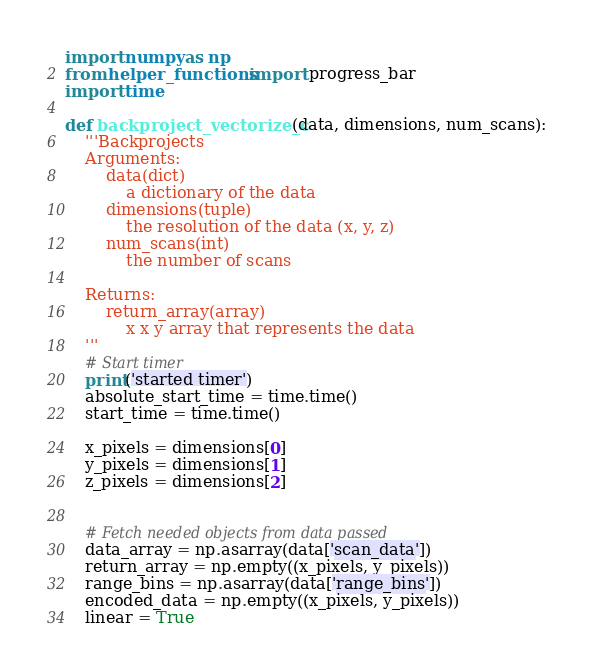<code> <loc_0><loc_0><loc_500><loc_500><_Cython_>import numpy as np
from helper_functions import progress_bar
import time

def backproject_vectorize_c(data, dimensions, num_scans):
    '''Backprojects
    Arguments:
        data(dict)
            a dictionary of the data
        dimensions(tuple)
            the resolution of the data (x, y, z)
        num_scans(int)
            the number of scans

    Returns:
        return_array(array)
            x x y array that represents the data
    '''
    # Start timer
    print('started timer')
    absolute_start_time = time.time()
    start_time = time.time()

    x_pixels = dimensions[0]
    y_pixels = dimensions[1]
    z_pixels = dimensions[2]


    # Fetch needed objects from data passed
    data_array = np.asarray(data['scan_data'])
    return_array = np.empty((x_pixels, y_pixels))
    range_bins = np.asarray(data['range_bins'])
    encoded_data = np.empty((x_pixels, y_pixels))
    linear = True
</code> 